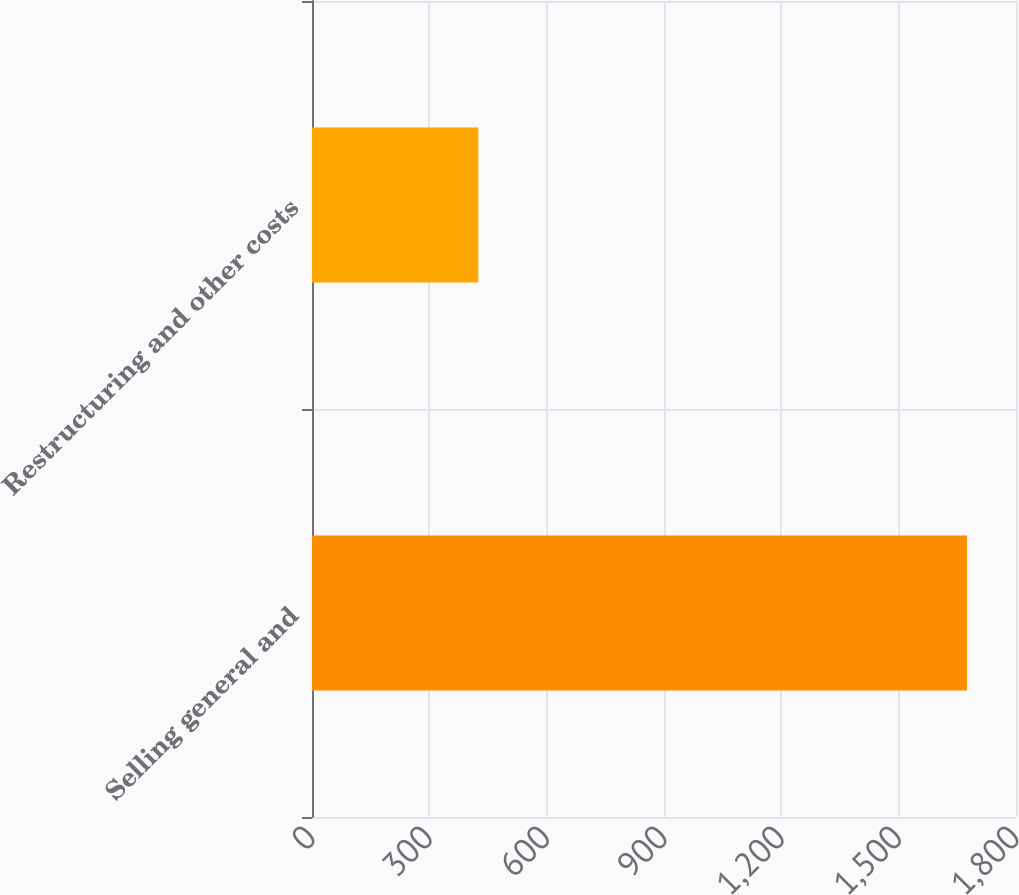<chart> <loc_0><loc_0><loc_500><loc_500><bar_chart><fcel>Selling general and<fcel>Restructuring and other costs<nl><fcel>1674.7<fcel>425.2<nl></chart> 